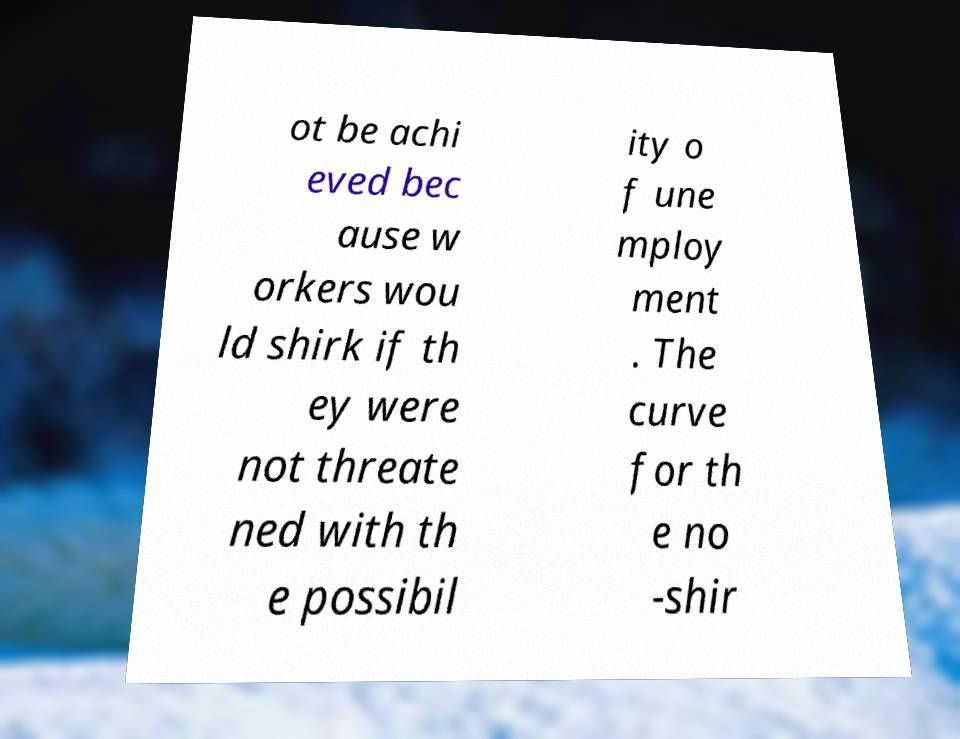Please read and relay the text visible in this image. What does it say? ot be achi eved bec ause w orkers wou ld shirk if th ey were not threate ned with th e possibil ity o f une mploy ment . The curve for th e no -shir 